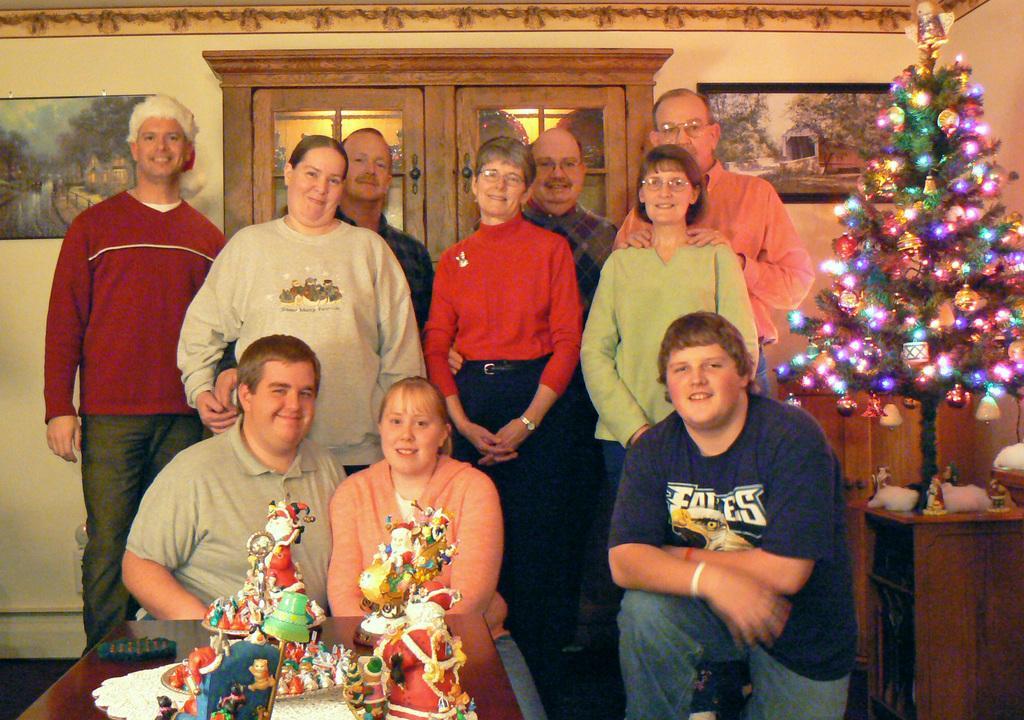Describe this image in one or two sentences. In this image I can see a table, few colorful objects on the table, few persons sitting, few persons standing and a christmas tree with decorative items attached to it on the table. In the background I can see the wall, few photo frames attached to the wall and brown colored doors. 